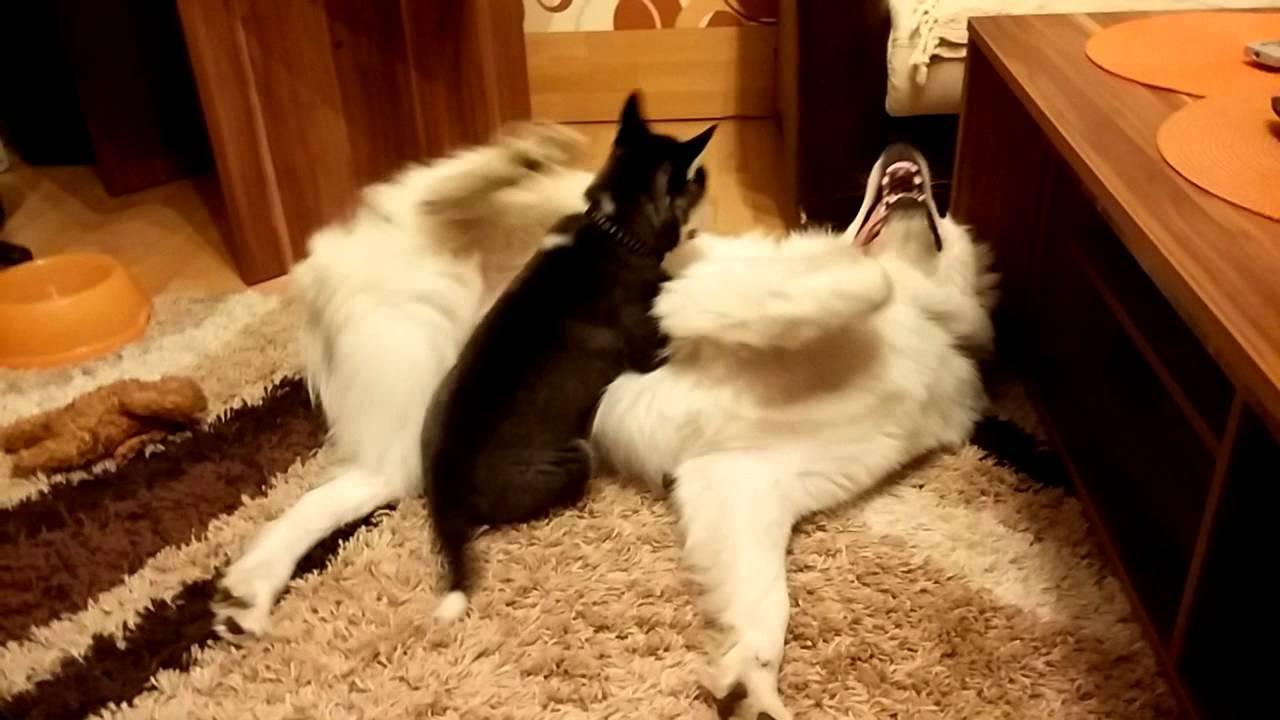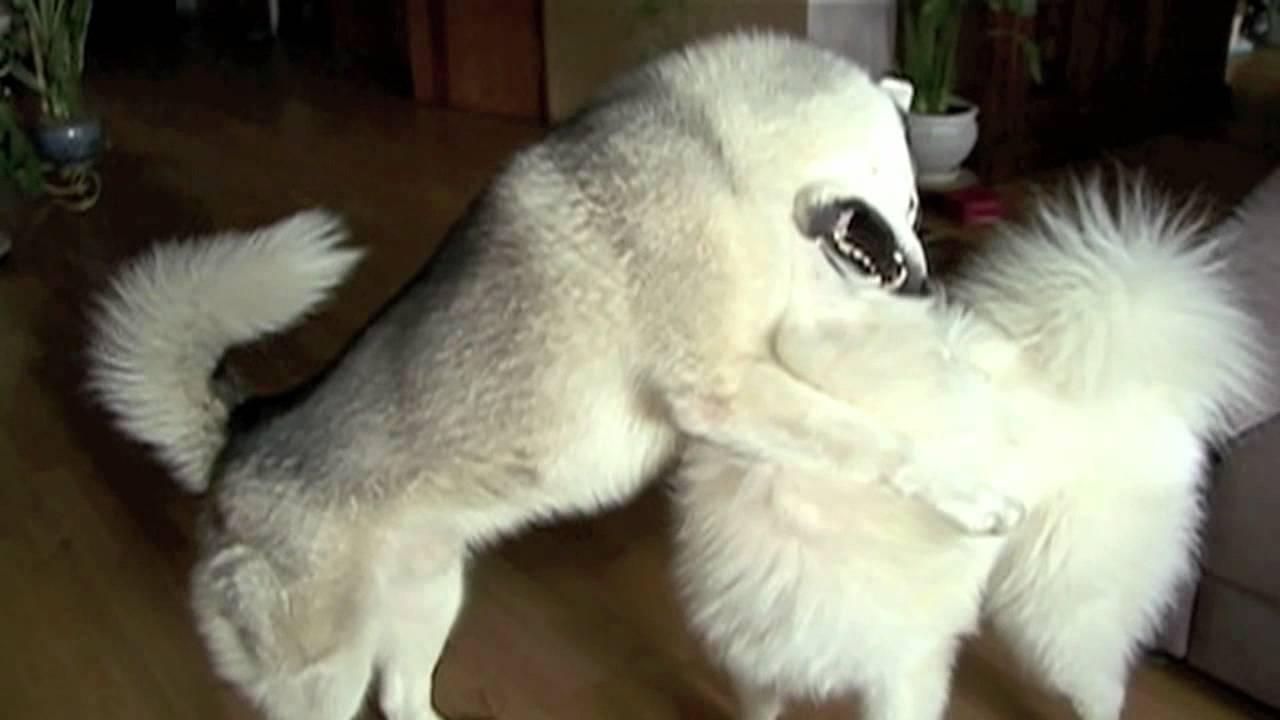The first image is the image on the left, the second image is the image on the right. Examine the images to the left and right. Is the description "In one of the images there is a small black dog on top of a big white dog that is laying on the floor." accurate? Answer yes or no. Yes. The first image is the image on the left, the second image is the image on the right. Given the left and right images, does the statement "A person wearing jeans is next to multiple dogs in one image." hold true? Answer yes or no. No. 